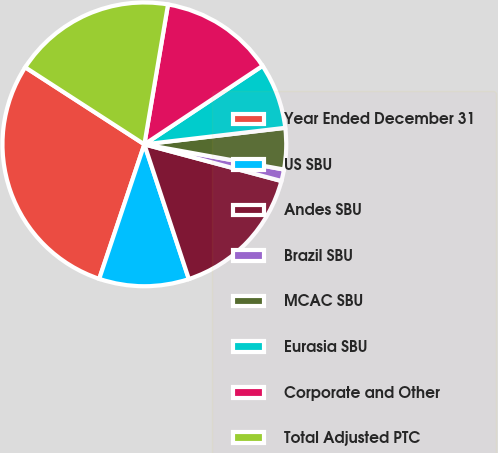Convert chart to OTSL. <chart><loc_0><loc_0><loc_500><loc_500><pie_chart><fcel>Year Ended December 31<fcel>US SBU<fcel>Andes SBU<fcel>Brazil SBU<fcel>MCAC SBU<fcel>Eurasia SBU<fcel>Corporate and Other<fcel>Total Adjusted PTC<nl><fcel>28.98%<fcel>10.23%<fcel>15.76%<fcel>1.32%<fcel>4.7%<fcel>7.47%<fcel>13.0%<fcel>18.53%<nl></chart> 